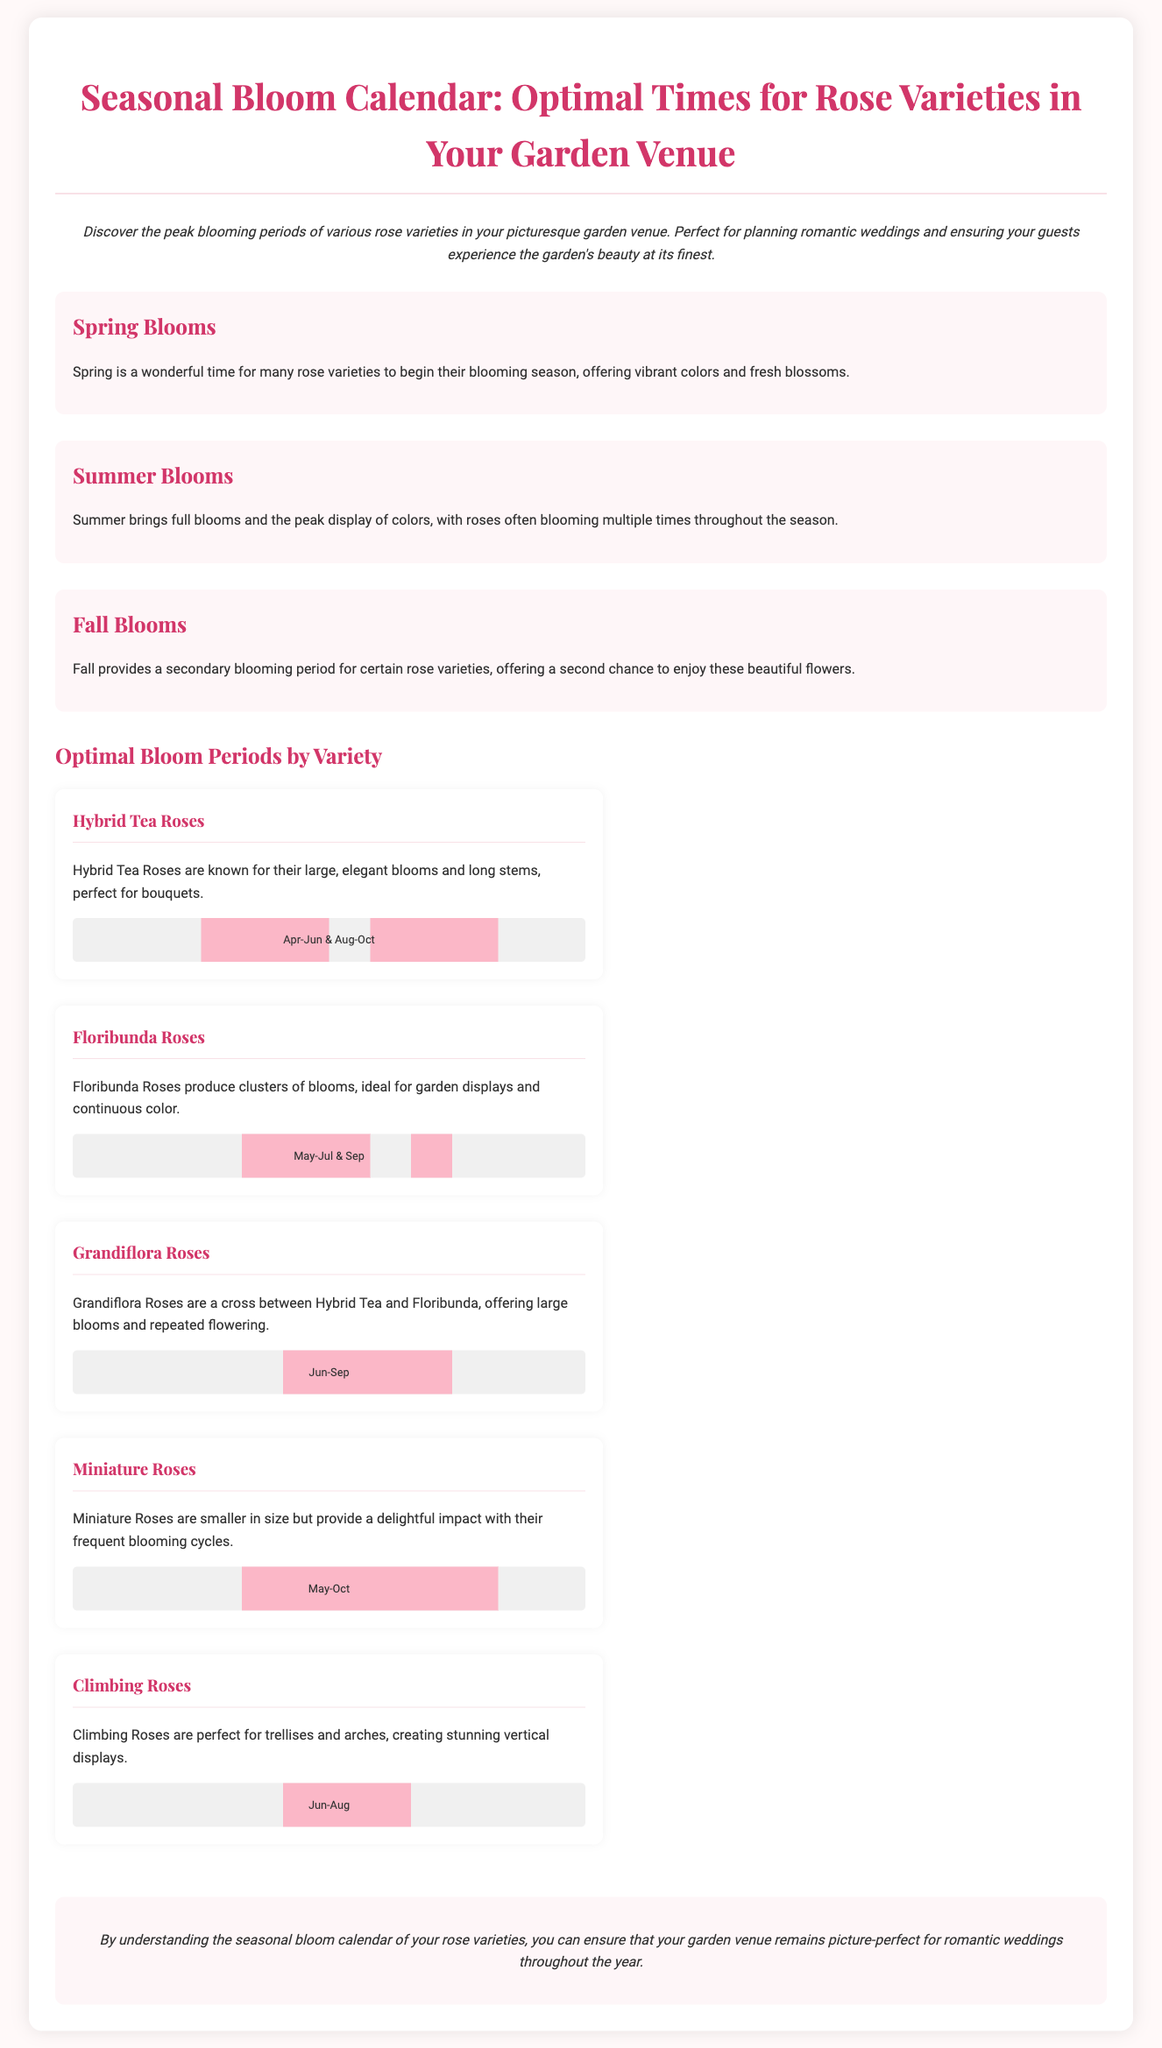what is the title of the document? The title is prominently displayed at the top of the document.
Answer: Seasonal Bloom Calendar: Optimal Times for Rose Varieties in Your Garden Venue which rose variety blooms in April to June and August to October? This information is provided in the section regarding Hybrid Tea Roses.
Answer: Hybrid Tea Roses what is the peak blooming period for Climbing Roses? The blooming period for Climbing Roses is specified in the chart associated with this variety.
Answer: June to August how many rose varieties are listed in the document? The document details five different rose varieties, as illustrated in the sections.
Answer: Five what phrase describes Miniature Roses? A descriptive phrase is included under each rose variety.
Answer: Smaller in size but provide a delightful impact which season offers a secondary blooming period for certain roses? This information is outlined in the scenario describing Fall Blooms.
Answer: Fall what type of roses are known for producing clusters of blooms? The description for Floribunda Roses indicates their blooming style.
Answer: Floribunda Roses when do Grandiflora Roses typically bloom? The blooming period is indicated in the respective section for Grandiflora Roses.
Answer: June to September 